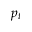<formula> <loc_0><loc_0><loc_500><loc_500>p _ { t }</formula> 